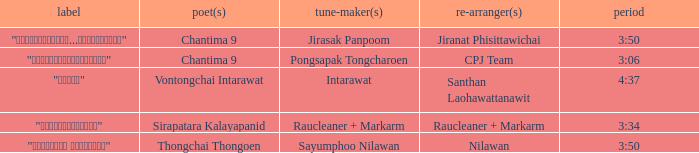Who was the arranger of "ขอโทษ"? Santhan Laohawattanawit. 